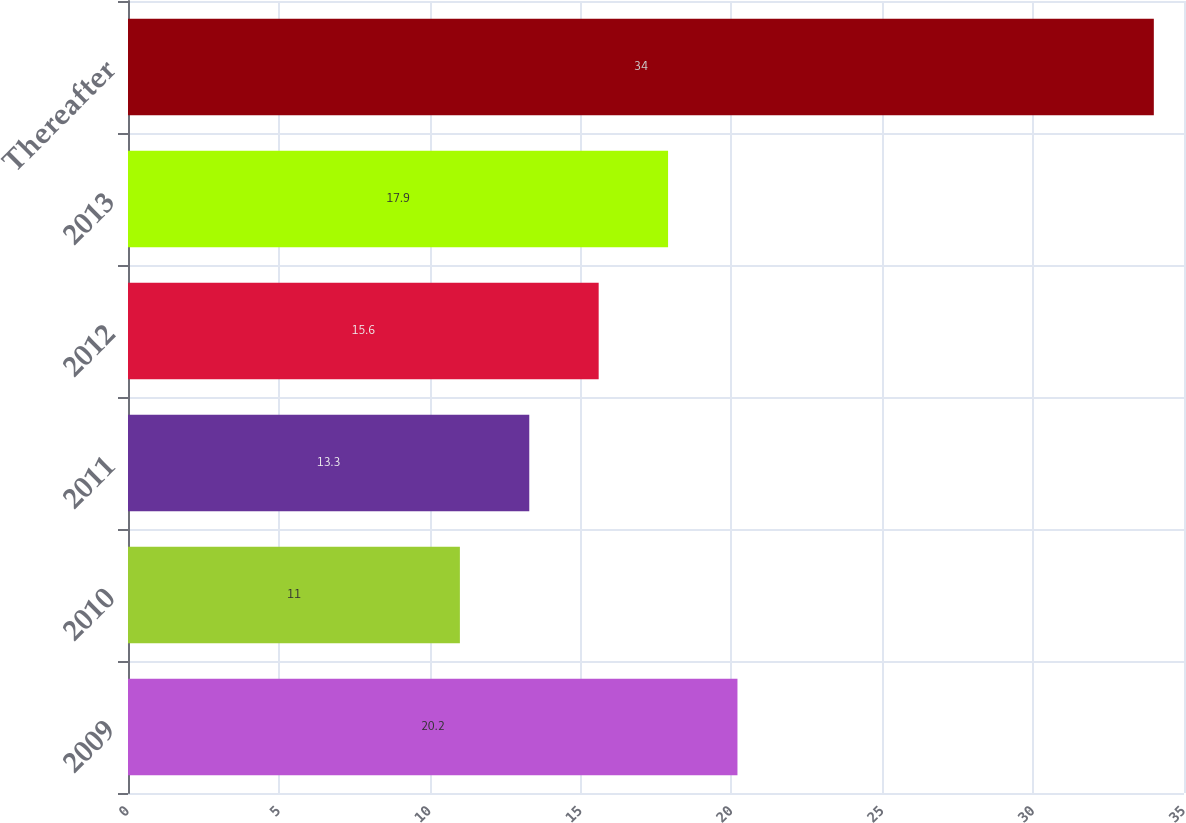Convert chart. <chart><loc_0><loc_0><loc_500><loc_500><bar_chart><fcel>2009<fcel>2010<fcel>2011<fcel>2012<fcel>2013<fcel>Thereafter<nl><fcel>20.2<fcel>11<fcel>13.3<fcel>15.6<fcel>17.9<fcel>34<nl></chart> 